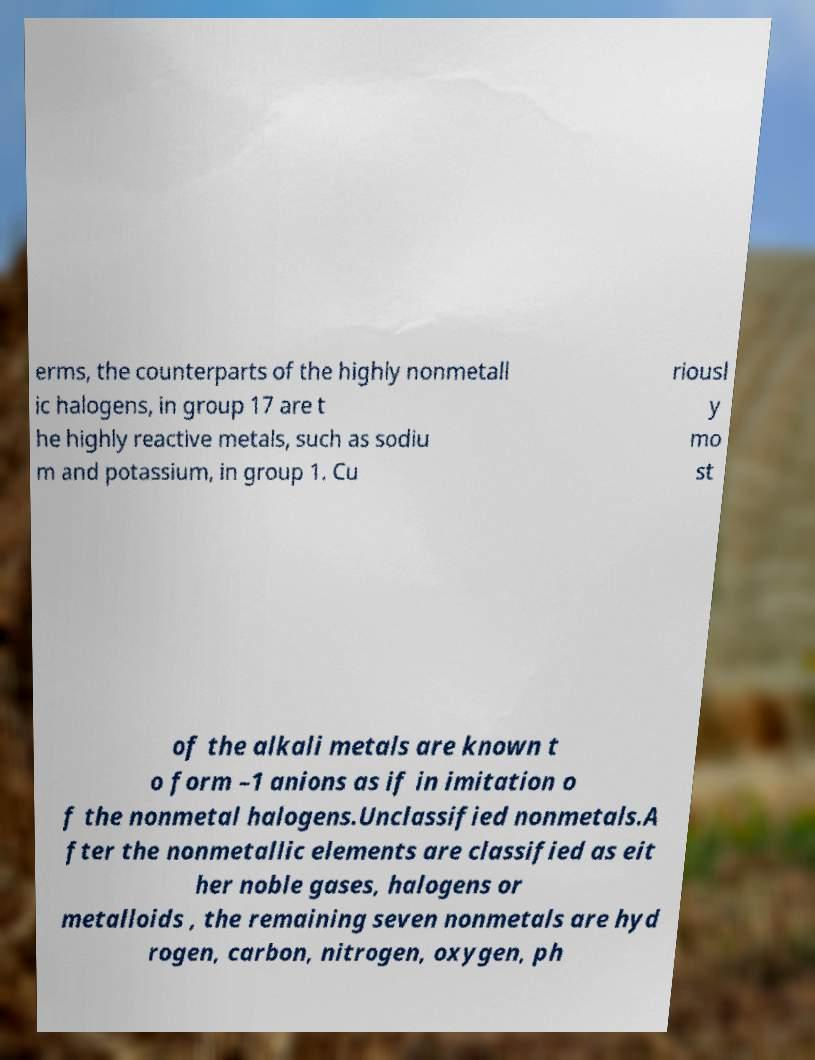Please identify and transcribe the text found in this image. erms, the counterparts of the highly nonmetall ic halogens, in group 17 are t he highly reactive metals, such as sodiu m and potassium, in group 1. Cu riousl y mo st of the alkali metals are known t o form –1 anions as if in imitation o f the nonmetal halogens.Unclassified nonmetals.A fter the nonmetallic elements are classified as eit her noble gases, halogens or metalloids , the remaining seven nonmetals are hyd rogen, carbon, nitrogen, oxygen, ph 